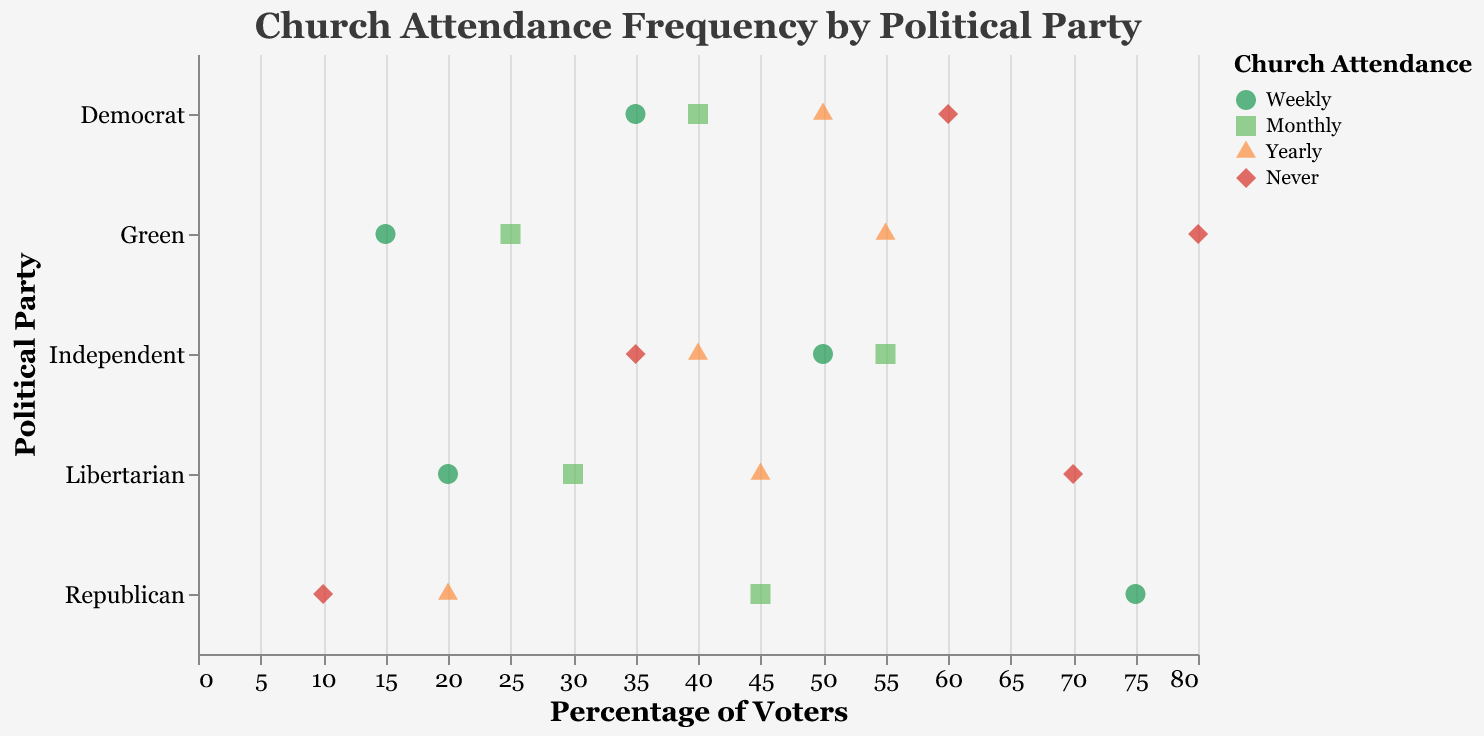What's the title of the figure? The title is displayed at the top of the figure.
Answer: Church Attendance Frequency by Political Party What are the different church attendance frequencies shown in the figure? The frequencies are represented using different colors and shapes in the legend: green circle for Weekly, light green square for Monthly, orange triangle for Yearly, and red diamond for Never.
Answer: Weekly, Monthly, Yearly, Never Which political party has the highest percentage of voters attending church weekly? Look for the highest weekly attendance value on the x-axis aligned with each party. The Republican party has the highest value at 75%.
Answer: Republican Which party has the most voters who never attend church? Find the highest value for "Never" on the x-axis. The Green party has the highest value at 80%.
Answer: Green How many parties have less than 50% of their voters attending church either weekly or monthly? Evaluate the values for "Weekly" and "Monthly" attendance for all parties. Libertarian (20, 30) and Green (15, 25) both have values below 50%.
Answer: 2 What is the difference in "Monthly" church attendance between Independents and Libertarians? Compare the percentage values for "Monthly" between the two parties: Independent (55%) and Libertarian (30%). The difference is 55 - 30 = 25%.
Answer: 25% Which frequency has the most varied attendance across different parties? Check the range of values for each frequency across parties by noting the highest and lowest values. "Never" has values ranging from 10 (Republican) to 80 (Green), showing the most variation.
Answer: Never On average, which label has the highest church attendance among parties, and what is the average value? Calculate the average for each frequency: Weekly (75+35+50+20+15)/5=39, Monthly (45+40+55+30+25)/5=39, Yearly (20+50+40+45+55)/5=42, Never (10+60+35+70+80)/5=51. Never has the highest average attendance.
Answer: Never, 51% How does the distribution of yearly church attendance compare across all parties? Examine the values for "Yearly" attendance for each party: Republican (20), Democrat (50), Independent (40), Libertarian (45), Green (55). The range is from 20 to 55.
Answer: Varies from 20 to 55 